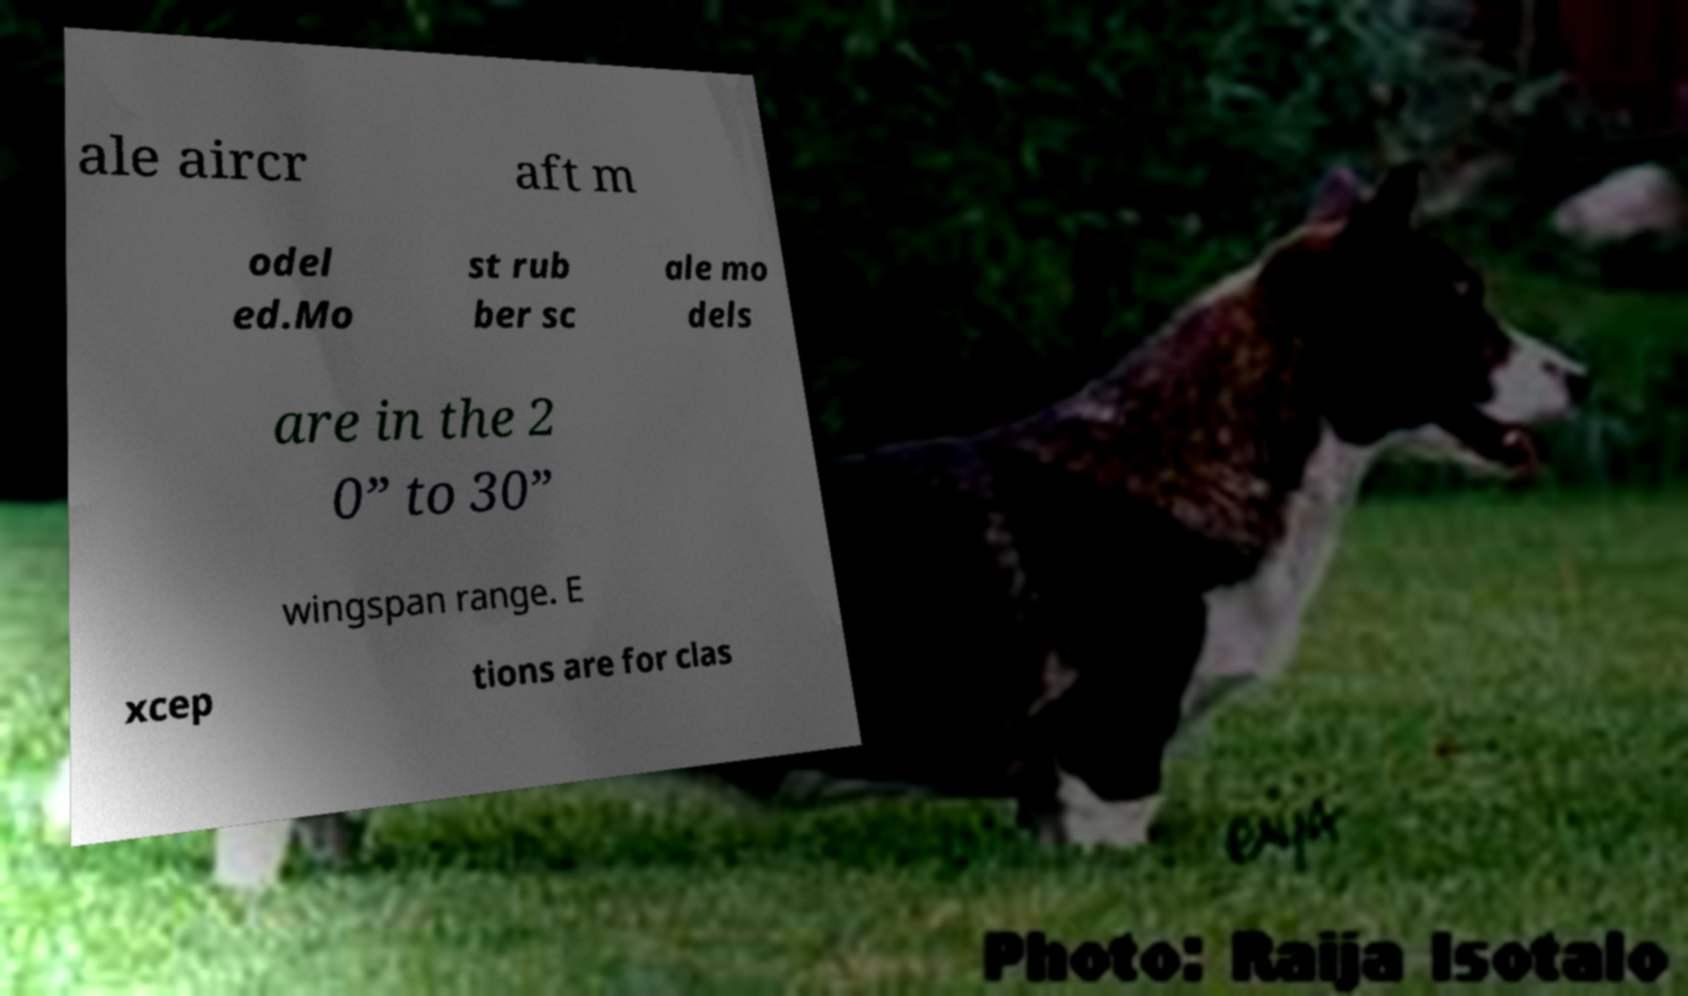I need the written content from this picture converted into text. Can you do that? ale aircr aft m odel ed.Mo st rub ber sc ale mo dels are in the 2 0” to 30” wingspan range. E xcep tions are for clas 